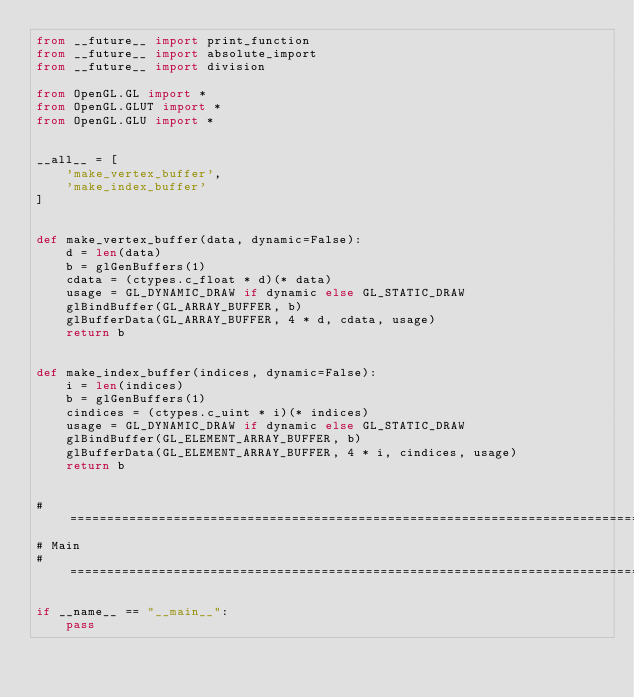<code> <loc_0><loc_0><loc_500><loc_500><_Python_>from __future__ import print_function
from __future__ import absolute_import
from __future__ import division

from OpenGL.GL import *
from OpenGL.GLUT import *
from OpenGL.GLU import *


__all__ = [
    'make_vertex_buffer',
    'make_index_buffer'
]


def make_vertex_buffer(data, dynamic=False):
    d = len(data)
    b = glGenBuffers(1)
    cdata = (ctypes.c_float * d)(* data)
    usage = GL_DYNAMIC_DRAW if dynamic else GL_STATIC_DRAW
    glBindBuffer(GL_ARRAY_BUFFER, b)
    glBufferData(GL_ARRAY_BUFFER, 4 * d, cdata, usage)
    return b


def make_index_buffer(indices, dynamic=False):
    i = len(indices)
    b = glGenBuffers(1)
    cindices = (ctypes.c_uint * i)(* indices)
    usage = GL_DYNAMIC_DRAW if dynamic else GL_STATIC_DRAW
    glBindBuffer(GL_ELEMENT_ARRAY_BUFFER, b)
    glBufferData(GL_ELEMENT_ARRAY_BUFFER, 4 * i, cindices, usage)
    return b


# ==============================================================================
# Main
# ==============================================================================

if __name__ == "__main__":
    pass
</code> 